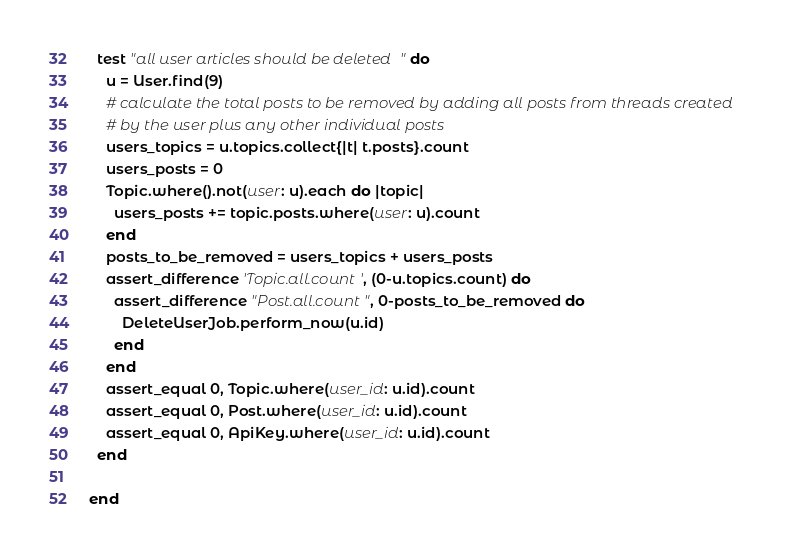<code> <loc_0><loc_0><loc_500><loc_500><_Ruby_>
  test "all user articles should be deleted" do
    u = User.find(9)
    # calculate the total posts to be removed by adding all posts from threads created
    # by the user plus any other individual posts
    users_topics = u.topics.collect{|t| t.posts}.count
    users_posts = 0
    Topic.where().not(user: u).each do |topic|
      users_posts += topic.posts.where(user: u).count
    end
    posts_to_be_removed = users_topics + users_posts
    assert_difference 'Topic.all.count', (0-u.topics.count) do
      assert_difference "Post.all.count", 0-posts_to_be_removed do
        DeleteUserJob.perform_now(u.id)
      end
    end
    assert_equal 0, Topic.where(user_id: u.id).count
    assert_equal 0, Post.where(user_id: u.id).count
    assert_equal 0, ApiKey.where(user_id: u.id).count
  end

end
</code> 